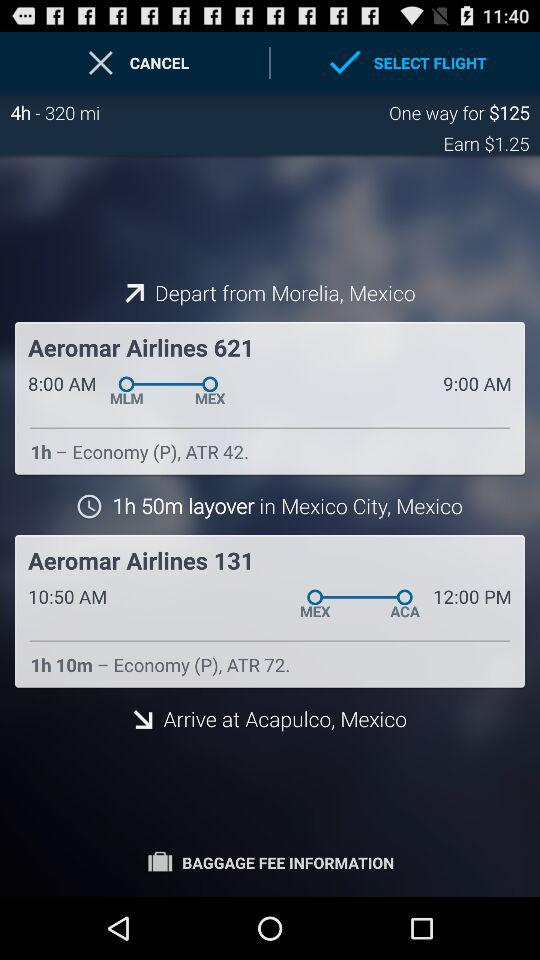How many flights are being offered to Mexico?
When the provided information is insufficient, respond with <no answer>. <no answer> 